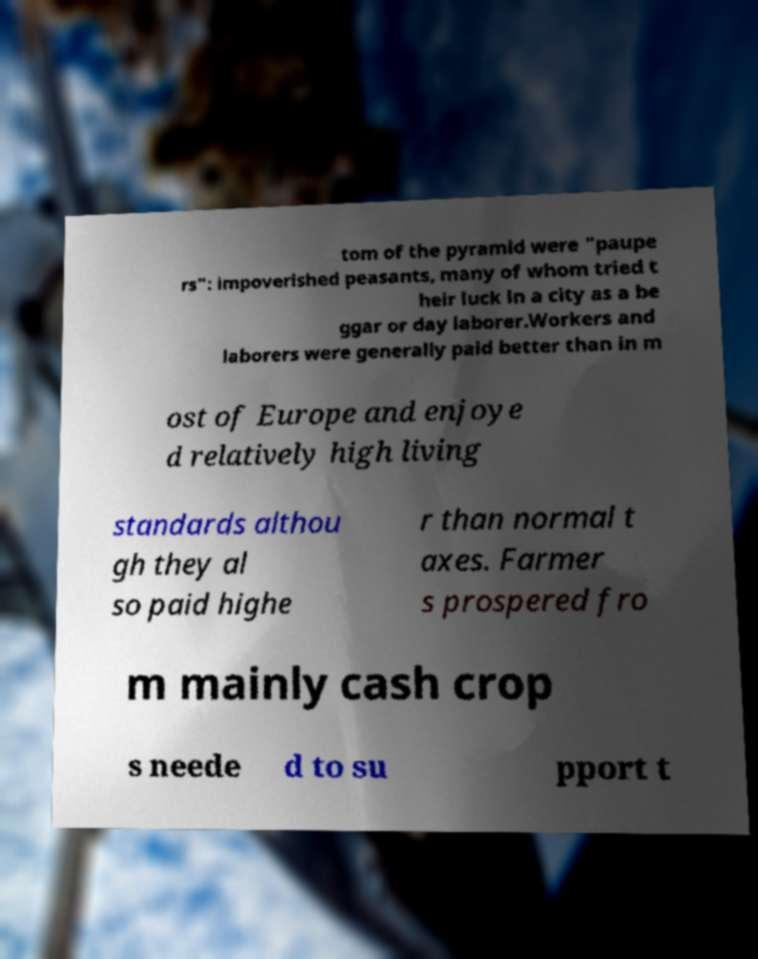Could you assist in decoding the text presented in this image and type it out clearly? tom of the pyramid were "paupe rs": impoverished peasants, many of whom tried t heir luck in a city as a be ggar or day laborer.Workers and laborers were generally paid better than in m ost of Europe and enjoye d relatively high living standards althou gh they al so paid highe r than normal t axes. Farmer s prospered fro m mainly cash crop s neede d to su pport t 